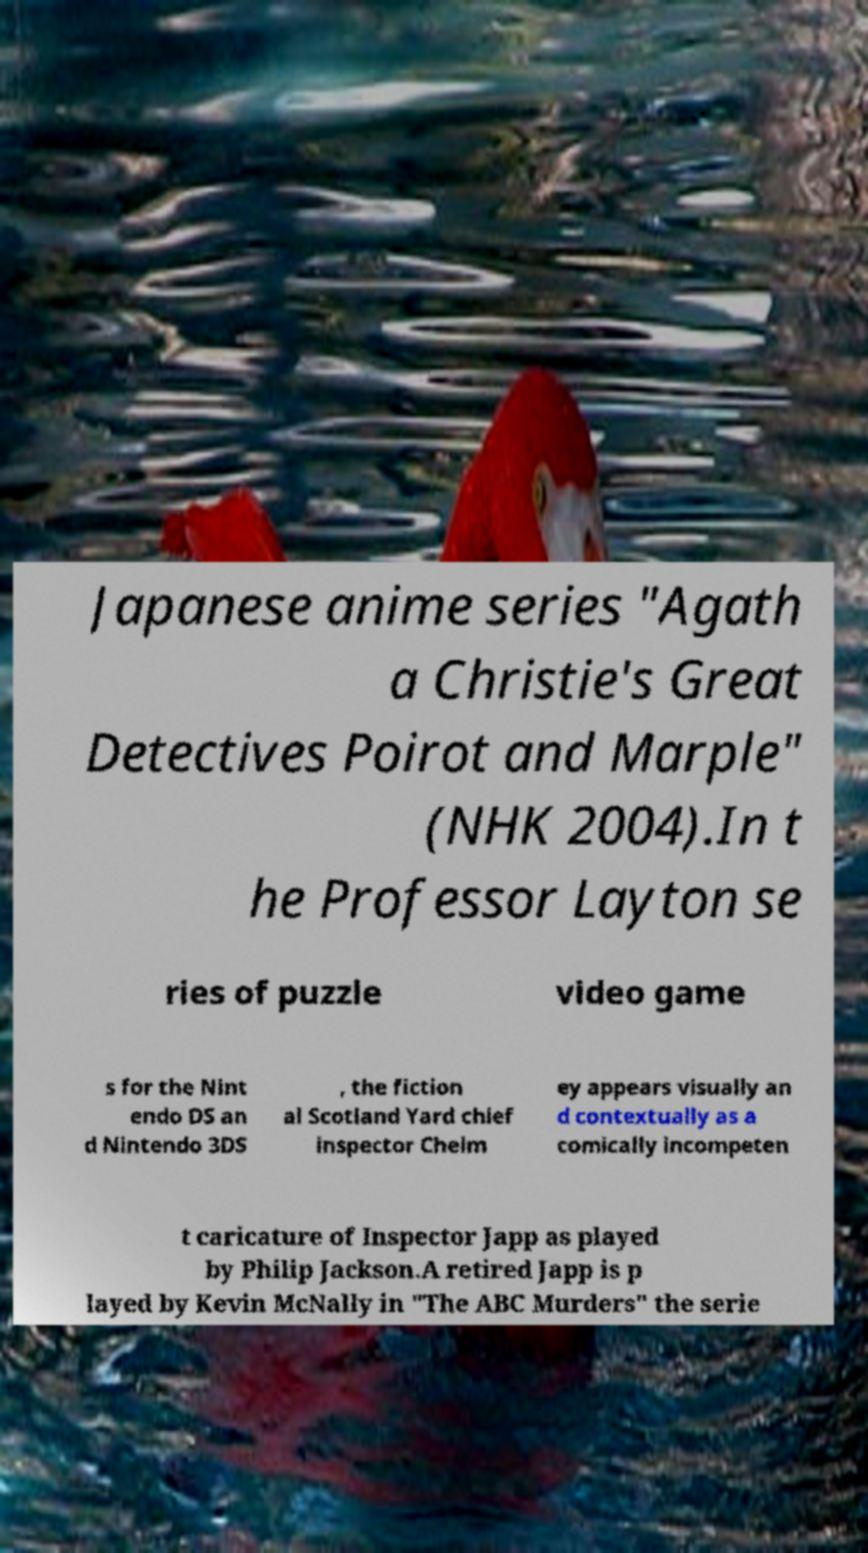I need the written content from this picture converted into text. Can you do that? Japanese anime series "Agath a Christie's Great Detectives Poirot and Marple" (NHK 2004).In t he Professor Layton se ries of puzzle video game s for the Nint endo DS an d Nintendo 3DS , the fiction al Scotland Yard chief inspector Chelm ey appears visually an d contextually as a comically incompeten t caricature of Inspector Japp as played by Philip Jackson.A retired Japp is p layed by Kevin McNally in "The ABC Murders" the serie 